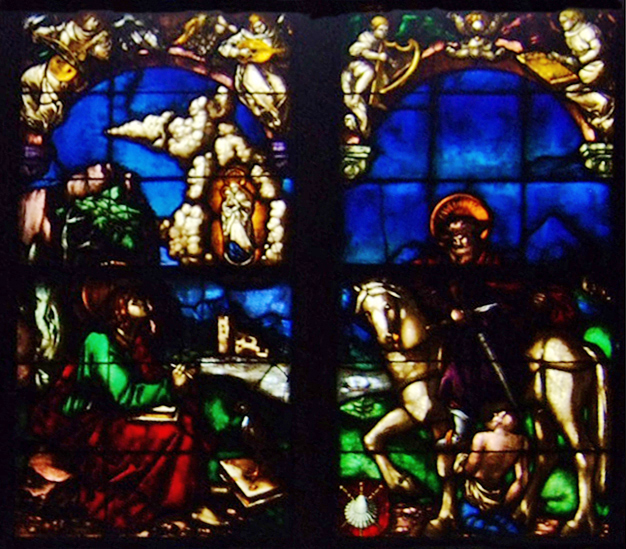Can you tell me more about the symbols held by the figures in the window? Certainly! In the stained glass window, both female figures are holding books and lilies. The book is a symbol often associated with knowledge, wisdom, or the Holy Scriptures, suggesting a connection to education or divine teachings. The lily is a symbol of purity and chastity, often linked to the Virgin Mary in Christian symbolism. Together, these symbols may suggest themes of spiritual purity and enlightenment. 